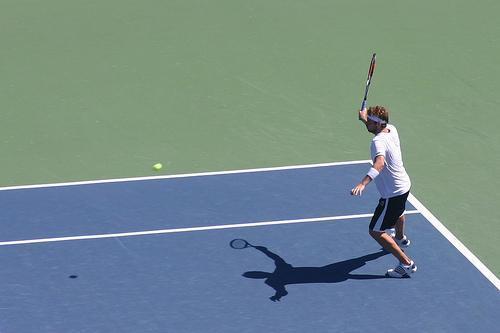How many players?
Give a very brief answer. 1. 